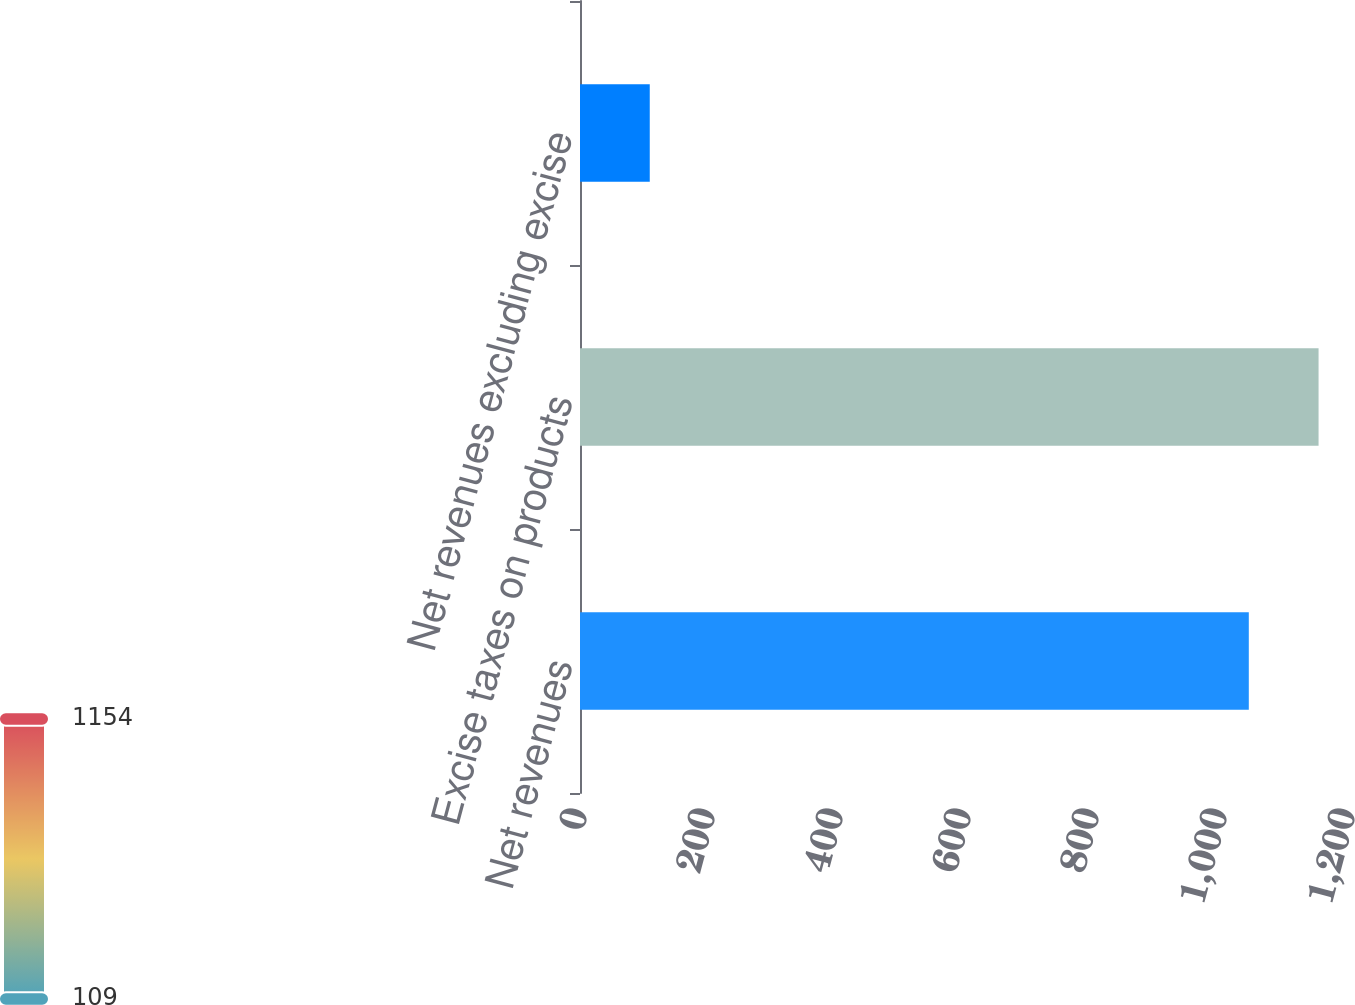<chart> <loc_0><loc_0><loc_500><loc_500><bar_chart><fcel>Net revenues<fcel>Excise taxes on products<fcel>Net revenues excluding excise<nl><fcel>1045<fcel>1154<fcel>109<nl></chart> 